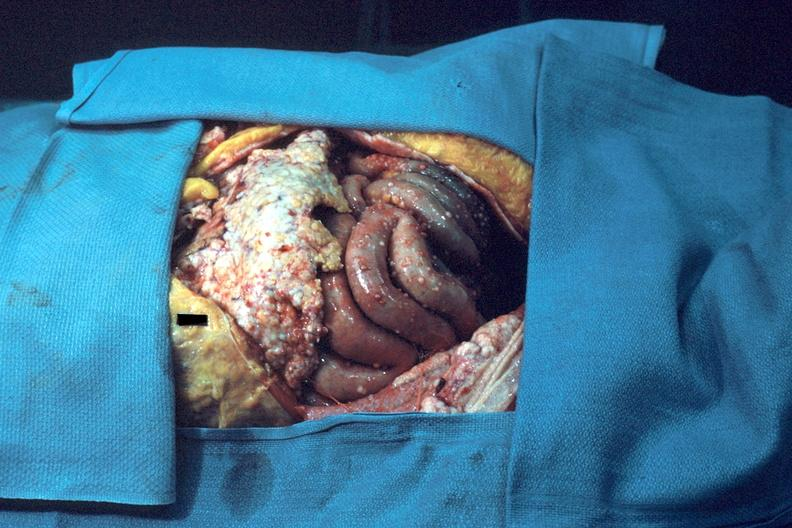what is present?
Answer the question using a single word or phrase. Carcinomatosis endometrium primary 